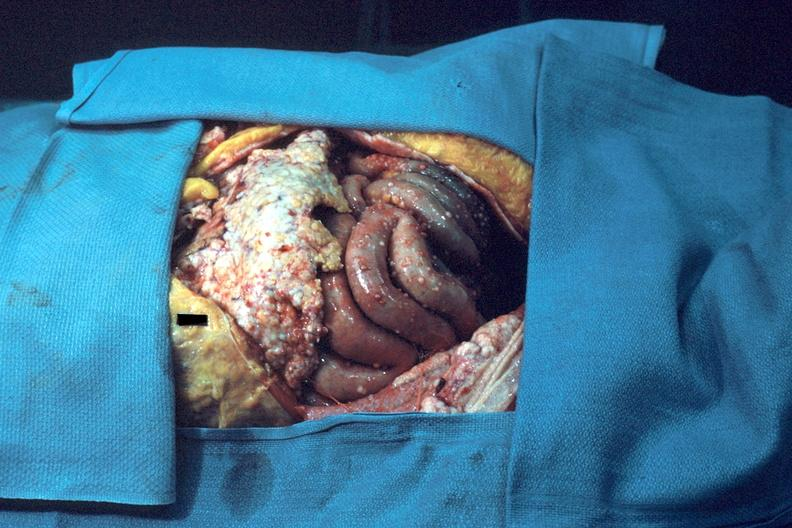what is present?
Answer the question using a single word or phrase. Carcinomatosis endometrium primary 